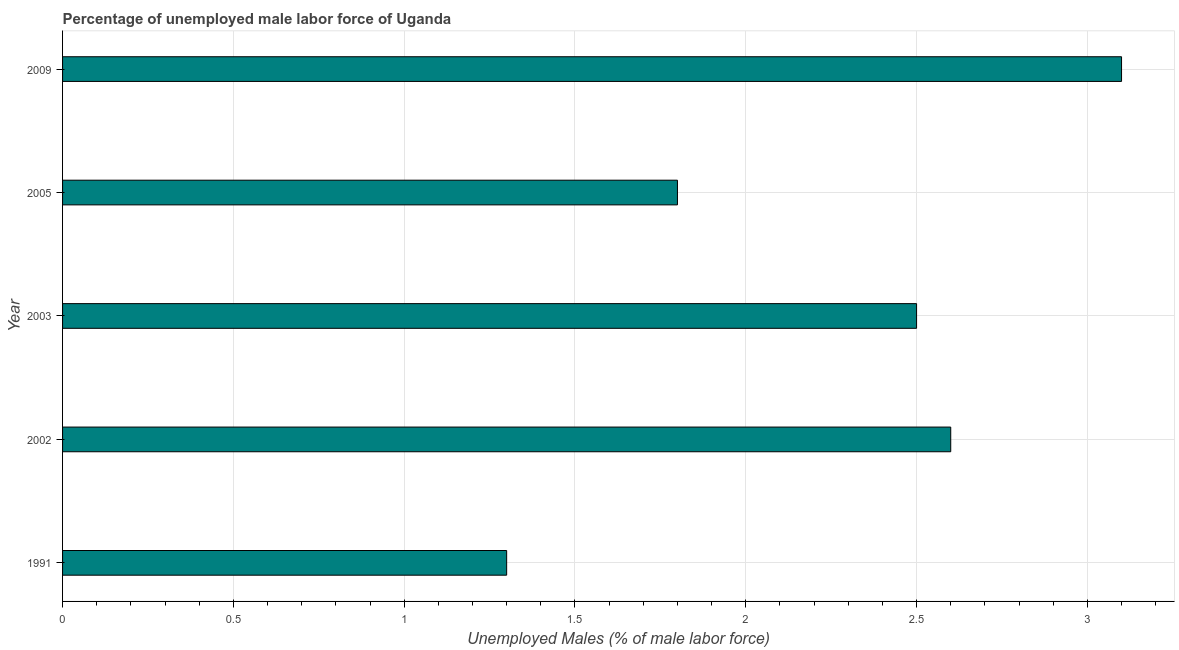Does the graph contain any zero values?
Keep it short and to the point. No. What is the title of the graph?
Your answer should be compact. Percentage of unemployed male labor force of Uganda. What is the label or title of the X-axis?
Offer a very short reply. Unemployed Males (% of male labor force). What is the label or title of the Y-axis?
Give a very brief answer. Year. What is the total unemployed male labour force in 2005?
Give a very brief answer. 1.8. Across all years, what is the maximum total unemployed male labour force?
Ensure brevity in your answer.  3.1. Across all years, what is the minimum total unemployed male labour force?
Give a very brief answer. 1.3. In which year was the total unemployed male labour force maximum?
Your response must be concise. 2009. What is the sum of the total unemployed male labour force?
Your answer should be very brief. 11.3. What is the average total unemployed male labour force per year?
Ensure brevity in your answer.  2.26. What is the median total unemployed male labour force?
Your response must be concise. 2.5. In how many years, is the total unemployed male labour force greater than 1.6 %?
Keep it short and to the point. 4. Do a majority of the years between 1991 and 2009 (inclusive) have total unemployed male labour force greater than 0.8 %?
Your answer should be compact. Yes. What is the ratio of the total unemployed male labour force in 1991 to that in 2003?
Provide a short and direct response. 0.52. Is the total unemployed male labour force in 2005 less than that in 2009?
Ensure brevity in your answer.  Yes. Is the difference between the total unemployed male labour force in 1991 and 2003 greater than the difference between any two years?
Make the answer very short. No. Is the sum of the total unemployed male labour force in 1991 and 2005 greater than the maximum total unemployed male labour force across all years?
Make the answer very short. No. What is the difference between the highest and the lowest total unemployed male labour force?
Provide a short and direct response. 1.8. How many bars are there?
Give a very brief answer. 5. Are all the bars in the graph horizontal?
Your response must be concise. Yes. How many years are there in the graph?
Your response must be concise. 5. What is the Unemployed Males (% of male labor force) in 1991?
Your response must be concise. 1.3. What is the Unemployed Males (% of male labor force) in 2002?
Your response must be concise. 2.6. What is the Unemployed Males (% of male labor force) of 2005?
Your answer should be very brief. 1.8. What is the Unemployed Males (% of male labor force) in 2009?
Provide a succinct answer. 3.1. What is the difference between the Unemployed Males (% of male labor force) in 1991 and 2003?
Ensure brevity in your answer.  -1.2. What is the difference between the Unemployed Males (% of male labor force) in 2005 and 2009?
Your response must be concise. -1.3. What is the ratio of the Unemployed Males (% of male labor force) in 1991 to that in 2002?
Offer a terse response. 0.5. What is the ratio of the Unemployed Males (% of male labor force) in 1991 to that in 2003?
Offer a very short reply. 0.52. What is the ratio of the Unemployed Males (% of male labor force) in 1991 to that in 2005?
Provide a short and direct response. 0.72. What is the ratio of the Unemployed Males (% of male labor force) in 1991 to that in 2009?
Provide a short and direct response. 0.42. What is the ratio of the Unemployed Males (% of male labor force) in 2002 to that in 2003?
Give a very brief answer. 1.04. What is the ratio of the Unemployed Males (% of male labor force) in 2002 to that in 2005?
Offer a very short reply. 1.44. What is the ratio of the Unemployed Males (% of male labor force) in 2002 to that in 2009?
Offer a terse response. 0.84. What is the ratio of the Unemployed Males (% of male labor force) in 2003 to that in 2005?
Keep it short and to the point. 1.39. What is the ratio of the Unemployed Males (% of male labor force) in 2003 to that in 2009?
Make the answer very short. 0.81. What is the ratio of the Unemployed Males (% of male labor force) in 2005 to that in 2009?
Offer a terse response. 0.58. 